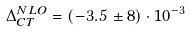Convert formula to latex. <formula><loc_0><loc_0><loc_500><loc_500>\Delta _ { C T } ^ { N L O } = ( - 3 . 5 \, \pm 8 ) \cdot 1 0 ^ { - 3 }</formula> 